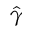Convert formula to latex. <formula><loc_0><loc_0><loc_500><loc_500>\hat { \gamma }</formula> 